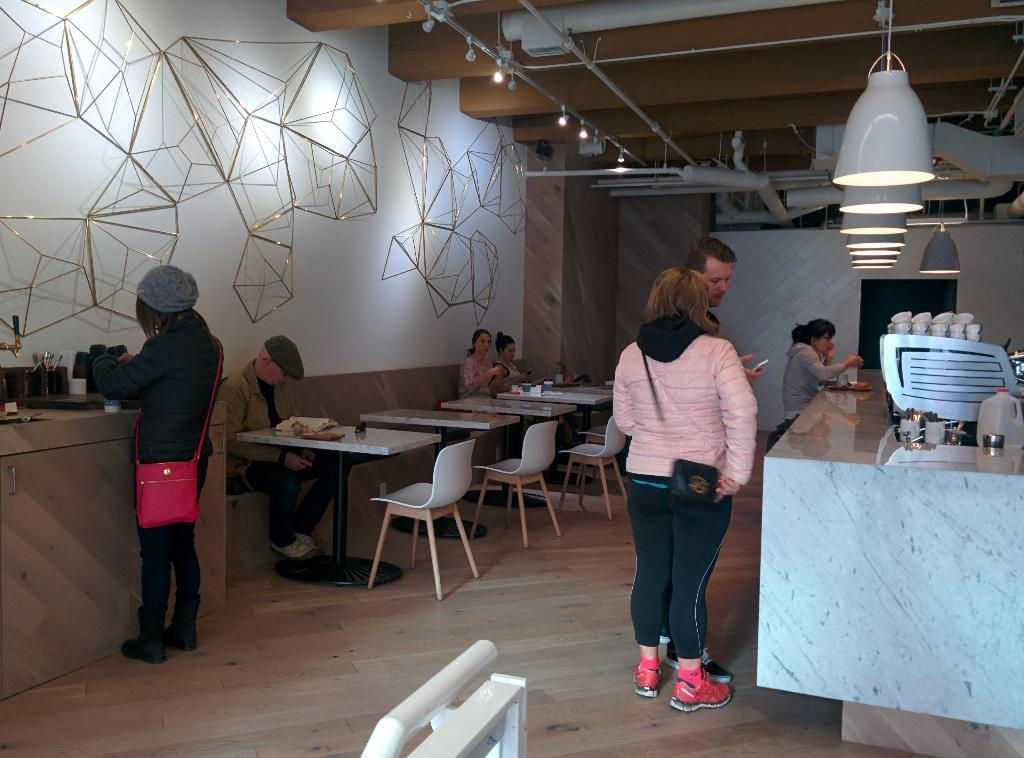What are the people in the image doing? There are people standing and sitting in the image. What are the sitting people using to support themselves? The sitting people are on chairs. What is in front of the sitting people? Tables are in front of the sitting people. What can be seen on the right side of the image? There are lights on the right side of the image. Can you tell me how the flock of birds is flying in the image? There are no birds or flocks present in the image. What is the best way to change the position of the lights in the image? The image is static, so it is not possible to change the position of the lights within the image. 